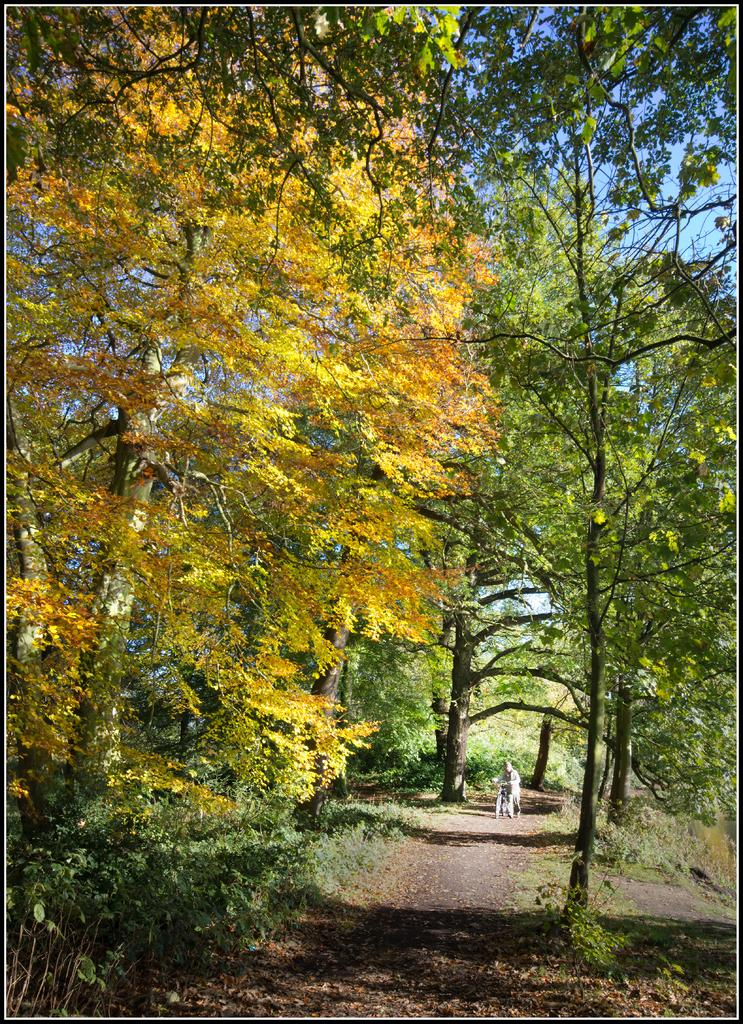What types of vegetation can be seen in the foreground of the picture? There are plants and trees in the foreground of the picture. What else can be found in the foreground of the picture? Dry leaves are present in the foreground of the picture. What is happening in the background of the picture? There is a person riding a bicycle in the background of the picture. What types of vegetation can be seen in the background of the picture? There are trees and plants in the background of the picture. How would you describe the weather in the image? The weather is sunny. Can you see any giants in the image? No, there are no giants present in the image. What type of soup is being served in the background of the image? There is no soup present in the image. 